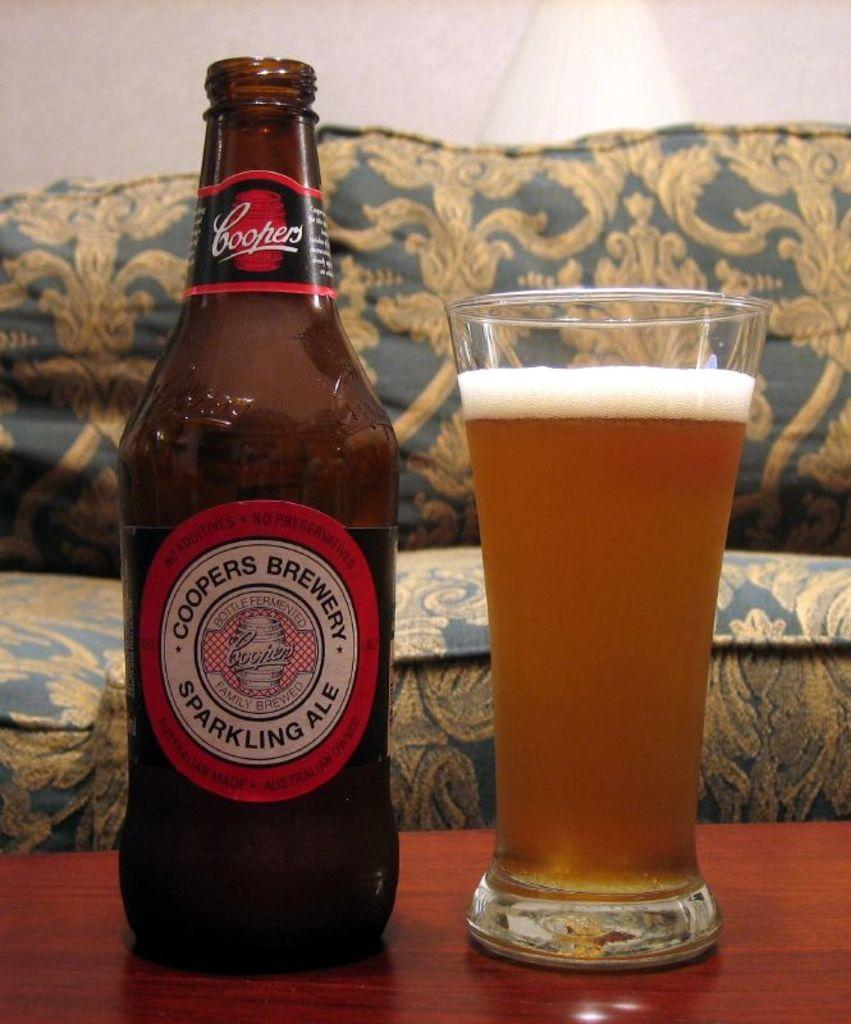<image>
Offer a succinct explanation of the picture presented. A full glass is next to a sparkling Ale sitting on a table. 